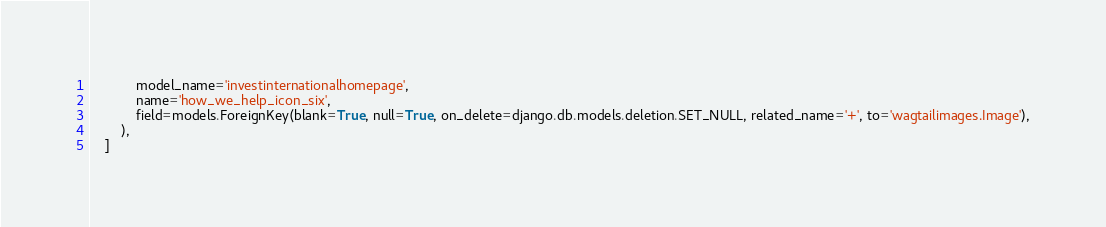<code> <loc_0><loc_0><loc_500><loc_500><_Python_>            model_name='investinternationalhomepage',
            name='how_we_help_icon_six',
            field=models.ForeignKey(blank=True, null=True, on_delete=django.db.models.deletion.SET_NULL, related_name='+', to='wagtailimages.Image'),
        ),
    ]
</code> 